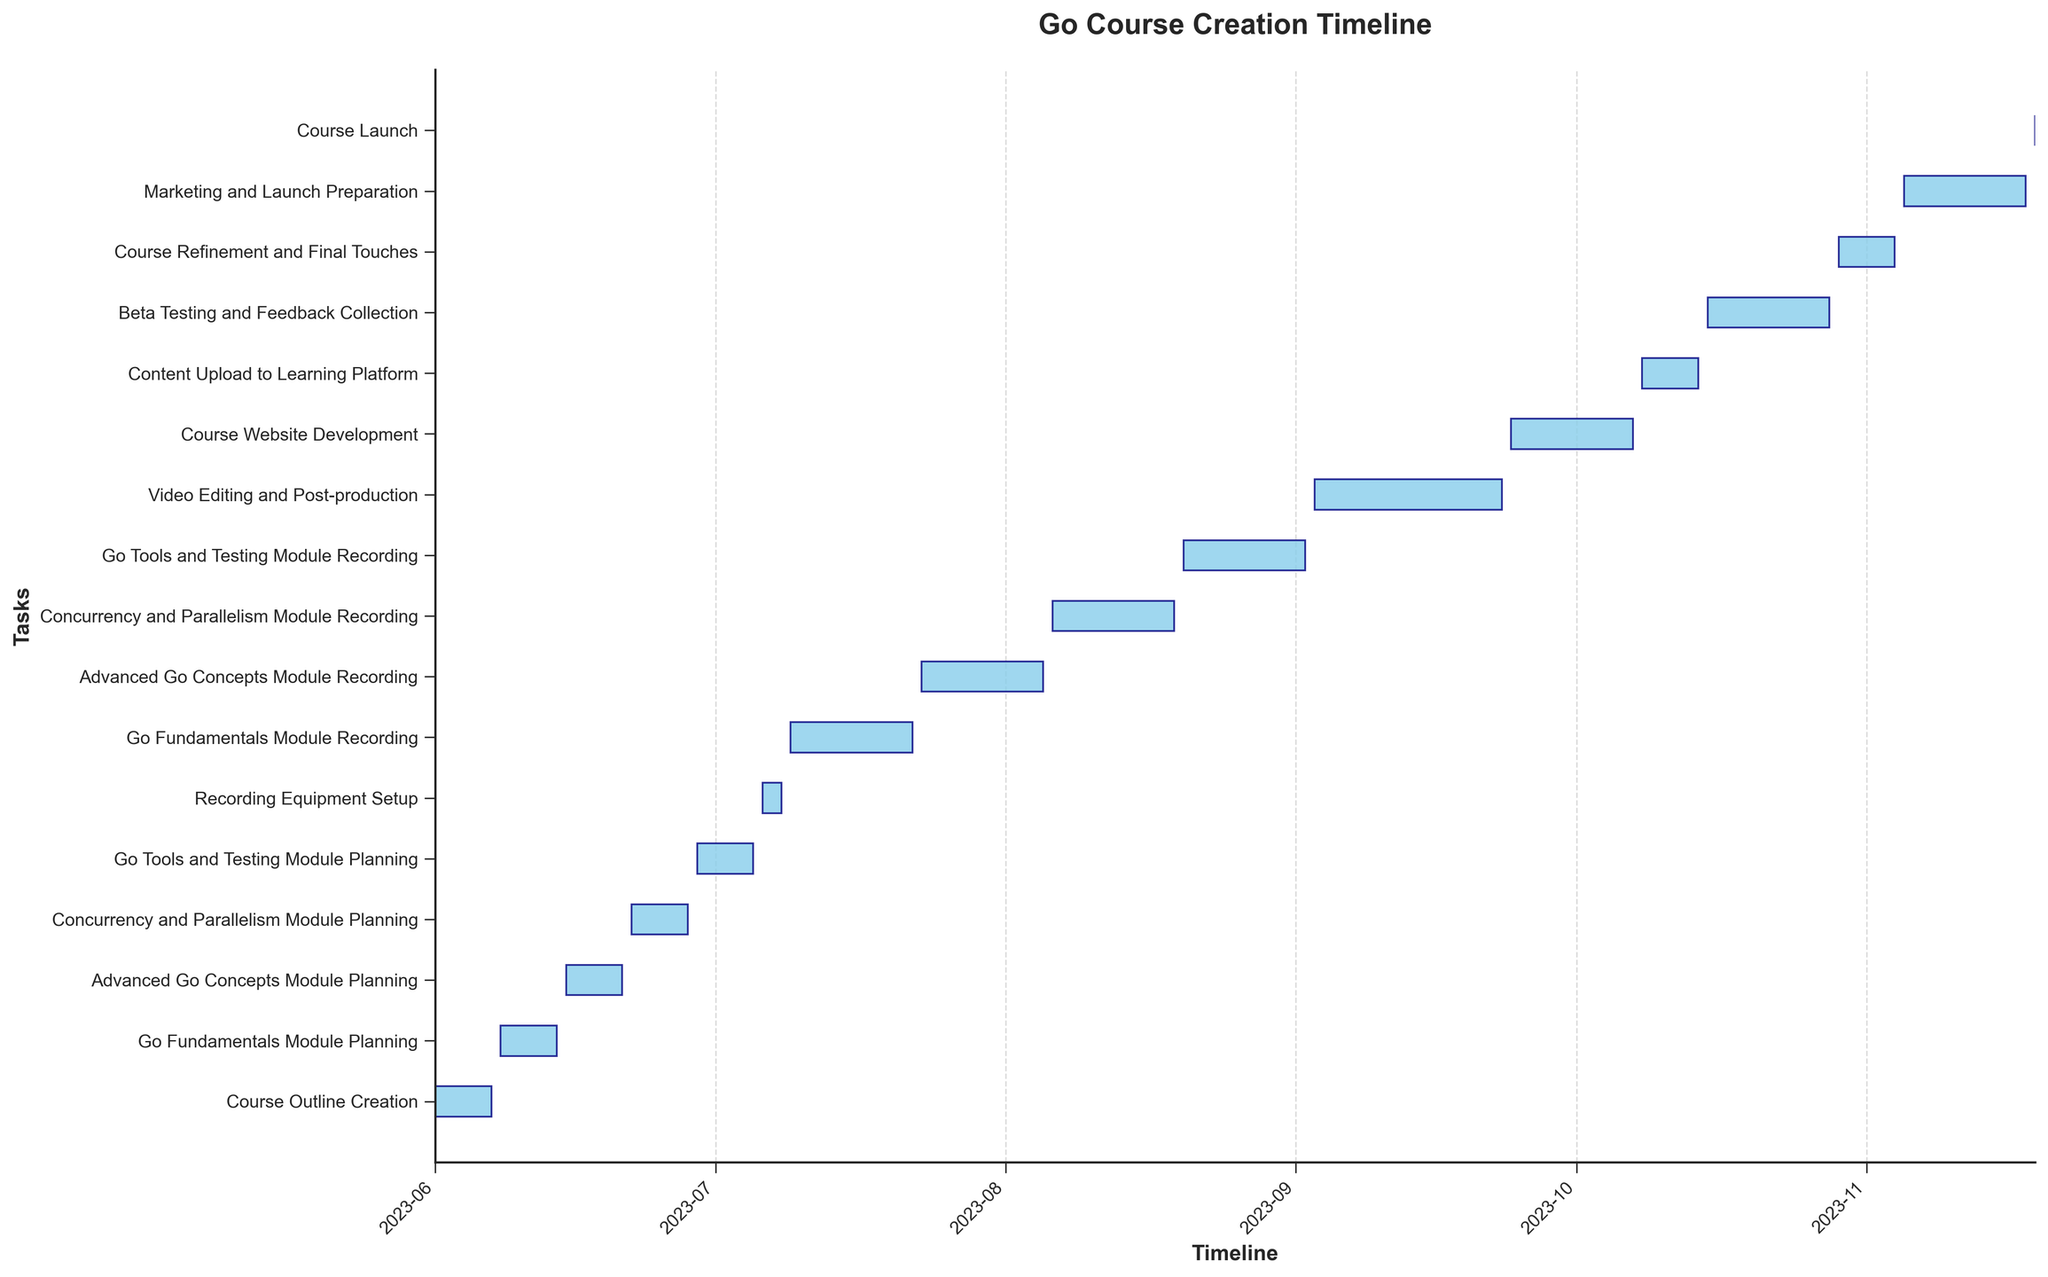What's the title of the figure? The title is typically located at the top of the figure. According to the code, the title of the Gantt chart is "Go Course Creation Timeline".
Answer: Go Course Creation Timeline Which task took the longest duration to complete? By comparing the lengths of the bars representing each task, the longest bar corresponds to the task with the maximum duration. "Video Editing and Post-production" occupies the largest timespan.
Answer: Video Editing and Post-production What is the color and appearance of the bars representing the tasks? The color of the bars representing tasks is specified as 'skyblue' with a navy edge color and an alpha transparency of 0.8, giving a semi-transparent blue appearance.
Answer: Semi-transparent blue with navy edges How many tasks are there in total, and which is the first task? Counting the number of horizontal bars gives the total number of tasks, and the first task is at the top of the Gantt chart. There are 16 tasks in total, with the first task being "Course Outline Creation".
Answer: 16, Course Outline Creation What's the duration of "Course Outline Creation"? To find the duration of "Course Outline Creation", subtract the start date from the end date, which are provided. The duration from June 1 to June 7 is 6 days.
Answer: 6 days What is the time span for "Advanced Go Concepts Module Planning"? The start and end dates for "Advanced Go Concepts Module Planning" are June 15 and June 21. By subtracting the start date from the end date, we find the duration to be 6 days.
Answer: 6 days Which task starts immediately after "Course Outline Creation"? By checking the timeline, the task following "Course Outline Creation" is "Go Fundamentals Module Planning" which starts on June 8.
Answer: Go Fundamentals Module Planning Which task is the shortest, and how long does it take? The shortest task can be identified by the length of the bar, and according to the data, "Recording Equipment Setup" takes the shortest duration of 3 days (from July 6 to July 8).
Answer: Recording Equipment Setup, 3 days What is the total duration from the beginning of the first task to the end of the last task? The entire timeline spans from the start date of the first task to the end date of the last task. The courses start on June 1 and finish on November 19, which totals 172 days.
Answer: 172 days Which task immediately precedes "Content Upload to Learning Platform"? By examining the timeline sequence before "Content Upload to Learning Platform," we see that "Course Website Development" precedes this task, ending on October 7 while "Content Upload to Learning Platform" starts on October 8.
Answer: Course Website Development 